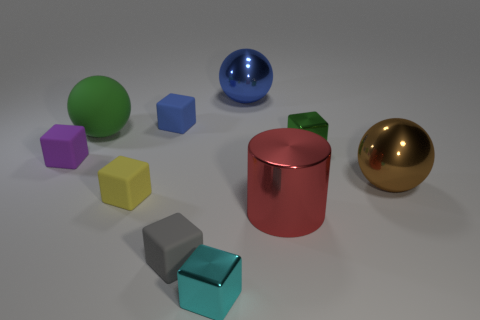Subtract all cyan cubes. How many cubes are left? 5 Subtract all small cyan cubes. How many cubes are left? 5 Subtract all cyan cylinders. Subtract all red balls. How many cylinders are left? 1 Subtract all cylinders. How many objects are left? 9 Add 9 green matte blocks. How many green matte blocks exist? 9 Subtract 0 cyan cylinders. How many objects are left? 10 Subtract all small purple shiny cylinders. Subtract all yellow matte things. How many objects are left? 9 Add 3 big objects. How many big objects are left? 7 